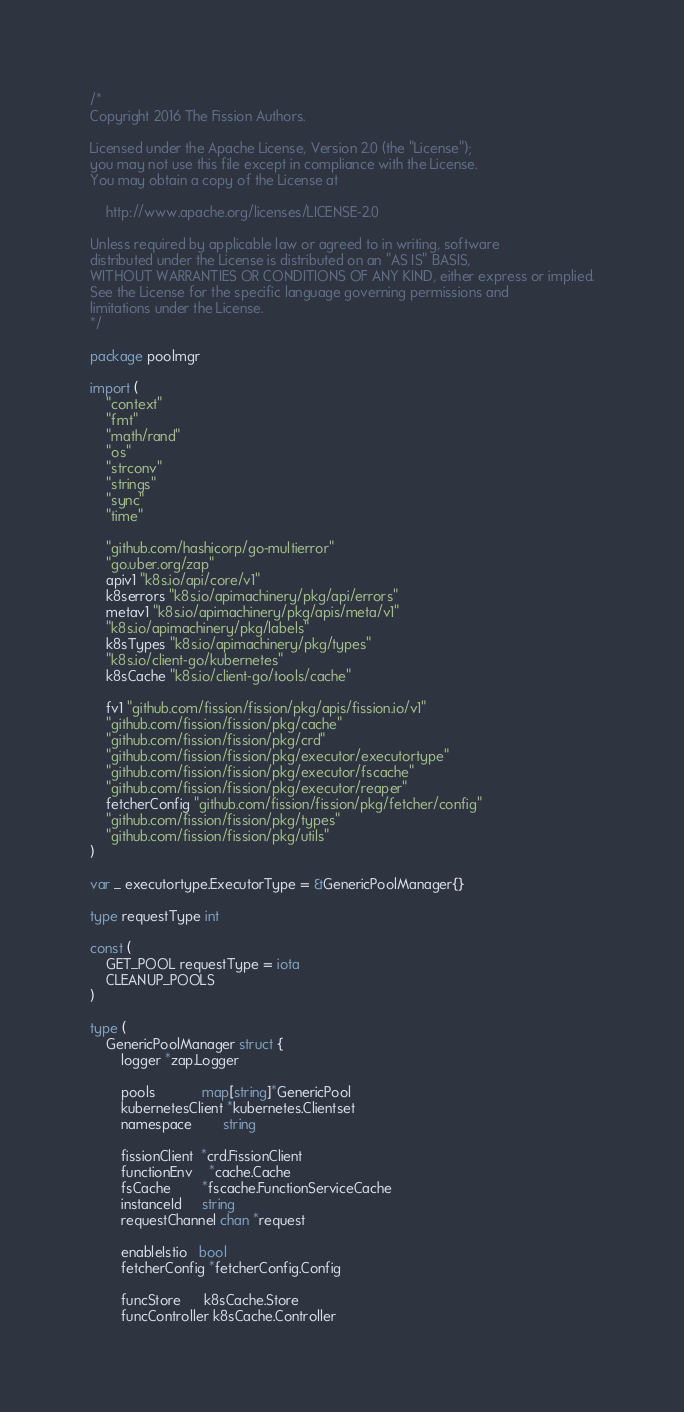<code> <loc_0><loc_0><loc_500><loc_500><_Go_>/*
Copyright 2016 The Fission Authors.

Licensed under the Apache License, Version 2.0 (the "License");
you may not use this file except in compliance with the License.
You may obtain a copy of the License at

    http://www.apache.org/licenses/LICENSE-2.0

Unless required by applicable law or agreed to in writing, software
distributed under the License is distributed on an "AS IS" BASIS,
WITHOUT WARRANTIES OR CONDITIONS OF ANY KIND, either express or implied.
See the License for the specific language governing permissions and
limitations under the License.
*/

package poolmgr

import (
	"context"
	"fmt"
	"math/rand"
	"os"
	"strconv"
	"strings"
	"sync"
	"time"

	"github.com/hashicorp/go-multierror"
	"go.uber.org/zap"
	apiv1 "k8s.io/api/core/v1"
	k8serrors "k8s.io/apimachinery/pkg/api/errors"
	metav1 "k8s.io/apimachinery/pkg/apis/meta/v1"
	"k8s.io/apimachinery/pkg/labels"
	k8sTypes "k8s.io/apimachinery/pkg/types"
	"k8s.io/client-go/kubernetes"
	k8sCache "k8s.io/client-go/tools/cache"

	fv1 "github.com/fission/fission/pkg/apis/fission.io/v1"
	"github.com/fission/fission/pkg/cache"
	"github.com/fission/fission/pkg/crd"
	"github.com/fission/fission/pkg/executor/executortype"
	"github.com/fission/fission/pkg/executor/fscache"
	"github.com/fission/fission/pkg/executor/reaper"
	fetcherConfig "github.com/fission/fission/pkg/fetcher/config"
	"github.com/fission/fission/pkg/types"
	"github.com/fission/fission/pkg/utils"
)

var _ executortype.ExecutorType = &GenericPoolManager{}

type requestType int

const (
	GET_POOL requestType = iota
	CLEANUP_POOLS
)

type (
	GenericPoolManager struct {
		logger *zap.Logger

		pools            map[string]*GenericPool
		kubernetesClient *kubernetes.Clientset
		namespace        string

		fissionClient  *crd.FissionClient
		functionEnv    *cache.Cache
		fsCache        *fscache.FunctionServiceCache
		instanceId     string
		requestChannel chan *request

		enableIstio   bool
		fetcherConfig *fetcherConfig.Config

		funcStore      k8sCache.Store
		funcController k8sCache.Controller</code> 